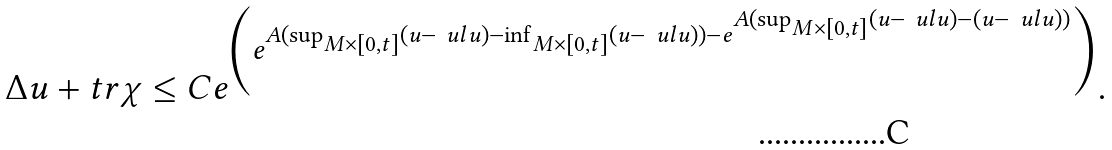Convert formula to latex. <formula><loc_0><loc_0><loc_500><loc_500>\Delta u + t r \chi \leq C e ^ { \left ( e ^ { A ( \sup _ { M \times [ 0 , t ] } ( u - \ u l u ) - \inf _ { M \times [ 0 , t ] } ( u - \ u l u ) ) - e ^ { A ( \sup _ { M \times [ 0 , t ] } ( u - \ u l u ) - ( u - \ u l u ) ) } } \right ) } .</formula> 